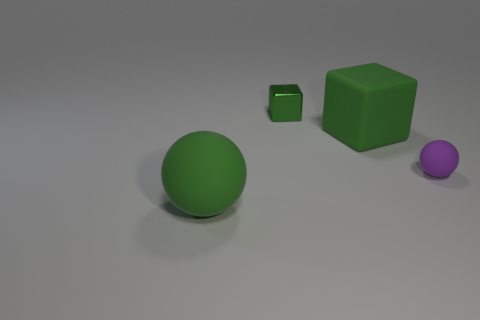The matte object on the right side of the large green thing that is behind the purple object is what color?
Keep it short and to the point. Purple. There is a large green object that is behind the large ball; what is it made of?
Your answer should be compact. Rubber. Are there fewer big green cubes than brown spheres?
Give a very brief answer. No. Does the small purple object have the same shape as the rubber thing left of the shiny thing?
Your answer should be compact. Yes. What is the shape of the thing that is right of the tiny green shiny block and to the left of the purple rubber object?
Your response must be concise. Cube. Is the number of tiny things that are on the right side of the metallic thing the same as the number of tiny matte objects that are behind the large cube?
Your answer should be very brief. No. There is a large object in front of the large green rubber cube; is its shape the same as the small green metal thing?
Provide a short and direct response. No. What number of yellow objects are either big things or blocks?
Your answer should be very brief. 0. There is another large thing that is the same shape as the purple matte object; what is it made of?
Offer a terse response. Rubber. There is a large object behind the small sphere; what shape is it?
Make the answer very short. Cube. 